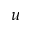Convert formula to latex. <formula><loc_0><loc_0><loc_500><loc_500>u</formula> 